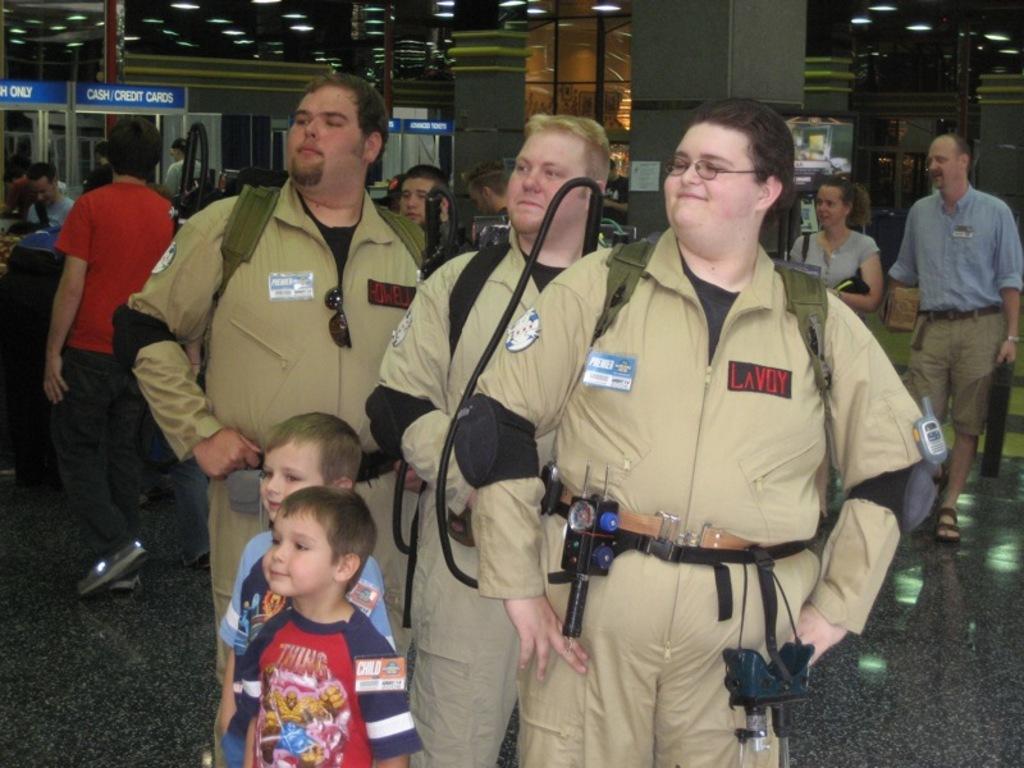How would you summarize this image in a sentence or two? In this image we can see people, pillars, lights, boards, and few objects. 